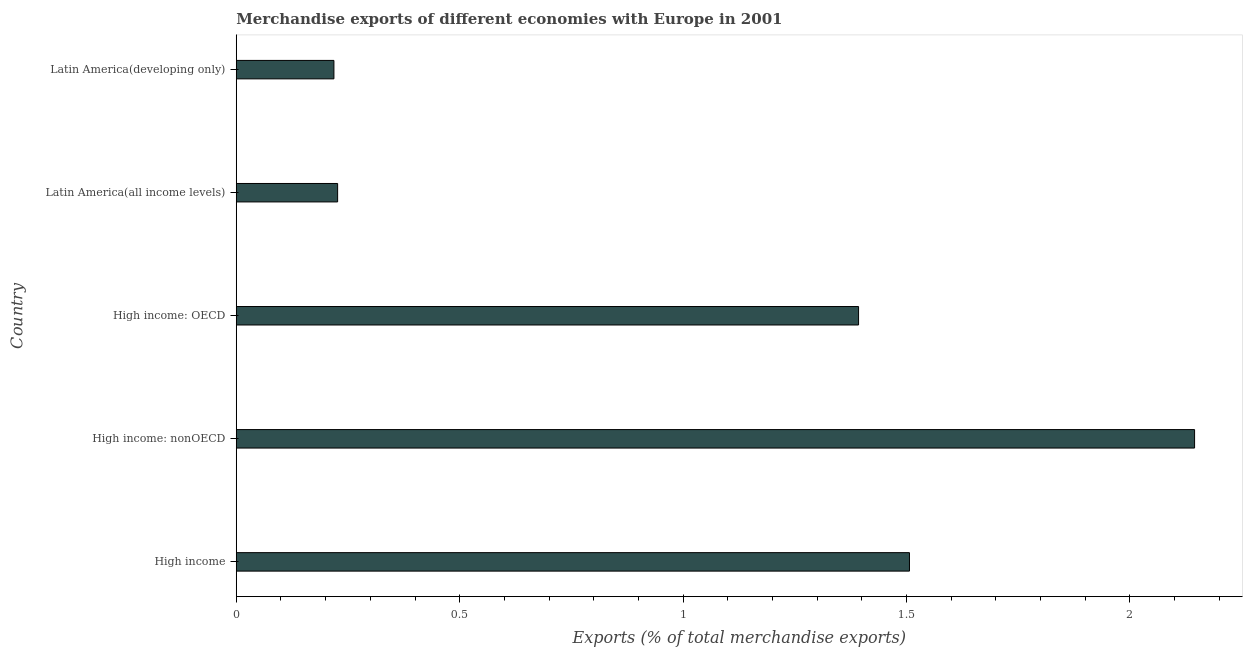Does the graph contain grids?
Offer a terse response. No. What is the title of the graph?
Your answer should be compact. Merchandise exports of different economies with Europe in 2001. What is the label or title of the X-axis?
Offer a terse response. Exports (% of total merchandise exports). What is the merchandise exports in Latin America(developing only)?
Your response must be concise. 0.22. Across all countries, what is the maximum merchandise exports?
Offer a terse response. 2.14. Across all countries, what is the minimum merchandise exports?
Your answer should be very brief. 0.22. In which country was the merchandise exports maximum?
Ensure brevity in your answer.  High income: nonOECD. In which country was the merchandise exports minimum?
Ensure brevity in your answer.  Latin America(developing only). What is the sum of the merchandise exports?
Your response must be concise. 5.49. What is the difference between the merchandise exports in High income: nonOECD and Latin America(developing only)?
Offer a terse response. 1.93. What is the average merchandise exports per country?
Keep it short and to the point. 1.1. What is the median merchandise exports?
Your response must be concise. 1.39. What is the ratio of the merchandise exports in High income to that in Latin America(all income levels)?
Offer a terse response. 6.64. Is the merchandise exports in High income: OECD less than that in High income: nonOECD?
Make the answer very short. Yes. What is the difference between the highest and the second highest merchandise exports?
Make the answer very short. 0.64. Is the sum of the merchandise exports in High income and High income: OECD greater than the maximum merchandise exports across all countries?
Provide a short and direct response. Yes. What is the difference between the highest and the lowest merchandise exports?
Your response must be concise. 1.93. How many countries are there in the graph?
Your answer should be compact. 5. What is the difference between two consecutive major ticks on the X-axis?
Keep it short and to the point. 0.5. Are the values on the major ticks of X-axis written in scientific E-notation?
Keep it short and to the point. No. What is the Exports (% of total merchandise exports) in High income?
Your response must be concise. 1.51. What is the Exports (% of total merchandise exports) in High income: nonOECD?
Your response must be concise. 2.14. What is the Exports (% of total merchandise exports) in High income: OECD?
Your answer should be very brief. 1.39. What is the Exports (% of total merchandise exports) in Latin America(all income levels)?
Offer a very short reply. 0.23. What is the Exports (% of total merchandise exports) in Latin America(developing only)?
Your answer should be compact. 0.22. What is the difference between the Exports (% of total merchandise exports) in High income and High income: nonOECD?
Keep it short and to the point. -0.64. What is the difference between the Exports (% of total merchandise exports) in High income and High income: OECD?
Your answer should be compact. 0.11. What is the difference between the Exports (% of total merchandise exports) in High income and Latin America(all income levels)?
Give a very brief answer. 1.28. What is the difference between the Exports (% of total merchandise exports) in High income and Latin America(developing only)?
Provide a short and direct response. 1.29. What is the difference between the Exports (% of total merchandise exports) in High income: nonOECD and High income: OECD?
Ensure brevity in your answer.  0.75. What is the difference between the Exports (% of total merchandise exports) in High income: nonOECD and Latin America(all income levels)?
Keep it short and to the point. 1.92. What is the difference between the Exports (% of total merchandise exports) in High income: nonOECD and Latin America(developing only)?
Give a very brief answer. 1.93. What is the difference between the Exports (% of total merchandise exports) in High income: OECD and Latin America(all income levels)?
Offer a terse response. 1.17. What is the difference between the Exports (% of total merchandise exports) in High income: OECD and Latin America(developing only)?
Your response must be concise. 1.17. What is the difference between the Exports (% of total merchandise exports) in Latin America(all income levels) and Latin America(developing only)?
Your response must be concise. 0.01. What is the ratio of the Exports (% of total merchandise exports) in High income to that in High income: nonOECD?
Offer a terse response. 0.7. What is the ratio of the Exports (% of total merchandise exports) in High income to that in High income: OECD?
Ensure brevity in your answer.  1.08. What is the ratio of the Exports (% of total merchandise exports) in High income to that in Latin America(all income levels)?
Make the answer very short. 6.64. What is the ratio of the Exports (% of total merchandise exports) in High income to that in Latin America(developing only)?
Give a very brief answer. 6.89. What is the ratio of the Exports (% of total merchandise exports) in High income: nonOECD to that in High income: OECD?
Keep it short and to the point. 1.54. What is the ratio of the Exports (% of total merchandise exports) in High income: nonOECD to that in Latin America(all income levels)?
Make the answer very short. 9.45. What is the ratio of the Exports (% of total merchandise exports) in High income: nonOECD to that in Latin America(developing only)?
Your answer should be compact. 9.81. What is the ratio of the Exports (% of total merchandise exports) in High income: OECD to that in Latin America(all income levels)?
Give a very brief answer. 6.14. What is the ratio of the Exports (% of total merchandise exports) in High income: OECD to that in Latin America(developing only)?
Offer a terse response. 6.37. What is the ratio of the Exports (% of total merchandise exports) in Latin America(all income levels) to that in Latin America(developing only)?
Offer a terse response. 1.04. 